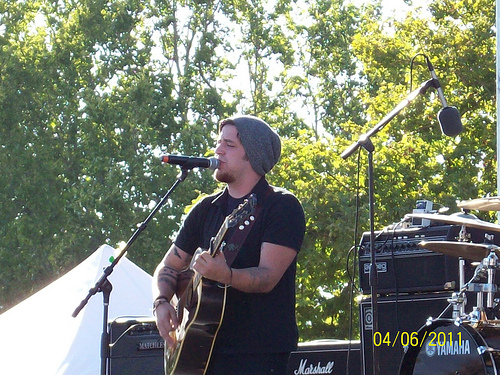<image>
Is the man in front of the mic? Yes. The man is positioned in front of the mic, appearing closer to the camera viewpoint. 